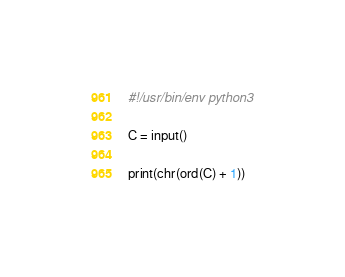Convert code to text. <code><loc_0><loc_0><loc_500><loc_500><_Python_>#!/usr/bin/env python3

C = input()

print(chr(ord(C) + 1))</code> 